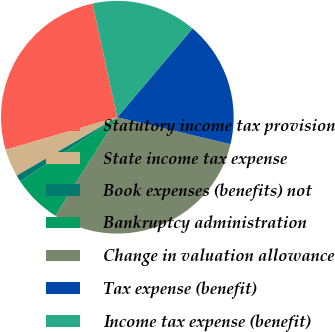Convert chart. <chart><loc_0><loc_0><loc_500><loc_500><pie_chart><fcel>Statutory income tax provision<fcel>State income tax expense<fcel>Book expenses (benefits) not<fcel>Bankruptcy administration<fcel>Change in valuation allowance<fcel>Tax expense (benefit)<fcel>Income tax expense (benefit)<nl><fcel>26.1%<fcel>3.85%<fcel>0.92%<fcel>6.78%<fcel>30.22%<fcel>17.54%<fcel>14.61%<nl></chart> 